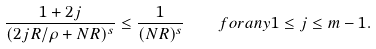<formula> <loc_0><loc_0><loc_500><loc_500>\frac { 1 + 2 j } { ( 2 j R / \rho + N R ) ^ { s } } \leq \frac { 1 } { ( N R ) ^ { s } } \quad f o r a n y 1 \leq j \leq m - 1 .</formula> 